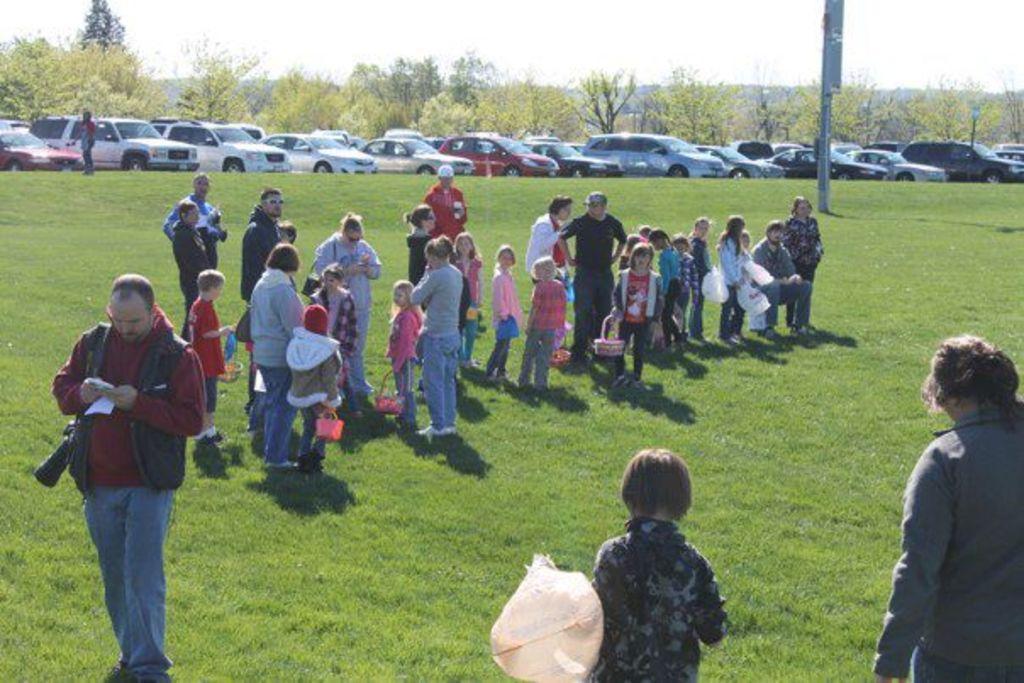Describe this image in one or two sentences. Here, we can see grass on the ground, there are some people standing and there are some kids standing on the grass, there is a pole, there are some cars parked in a queue, there are some green color trees, at the top there is a sky. 